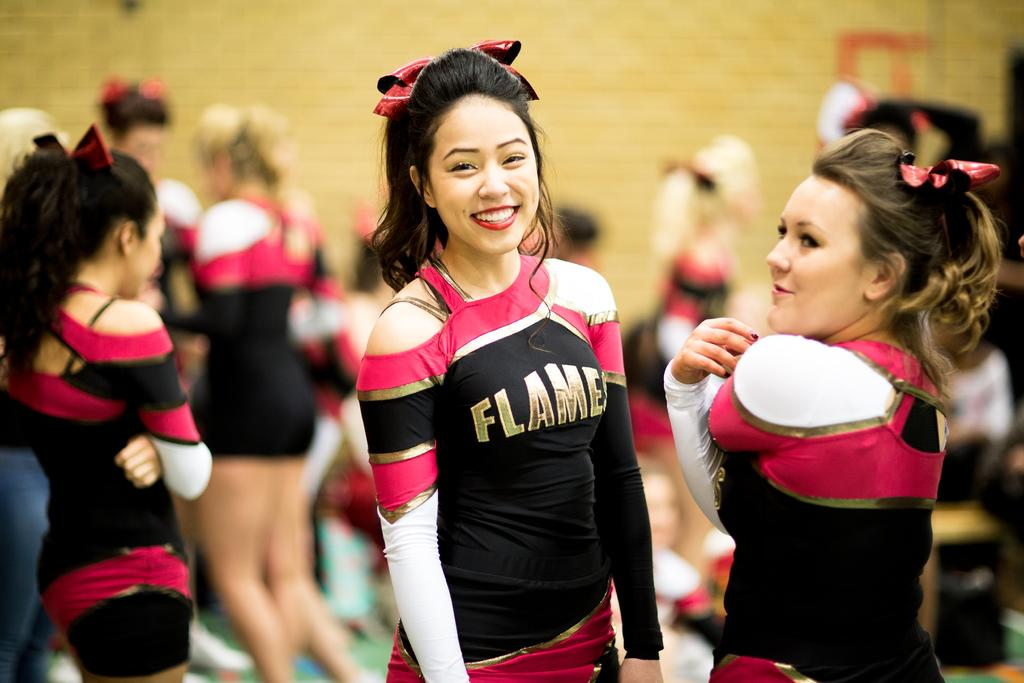<image>
Summarize the visual content of the image. A group of cheerleaders have the word "Flames" written on their uniforms. 